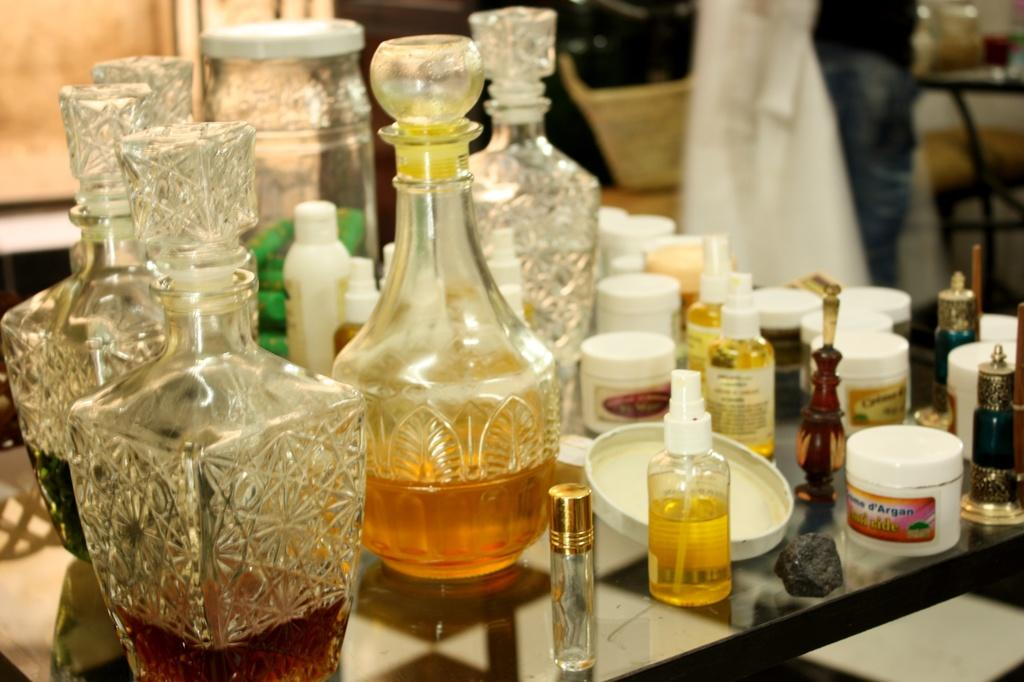<image>
Give a short and clear explanation of the subsequent image. A small white cosmetics jar says d'Argan on the label. 